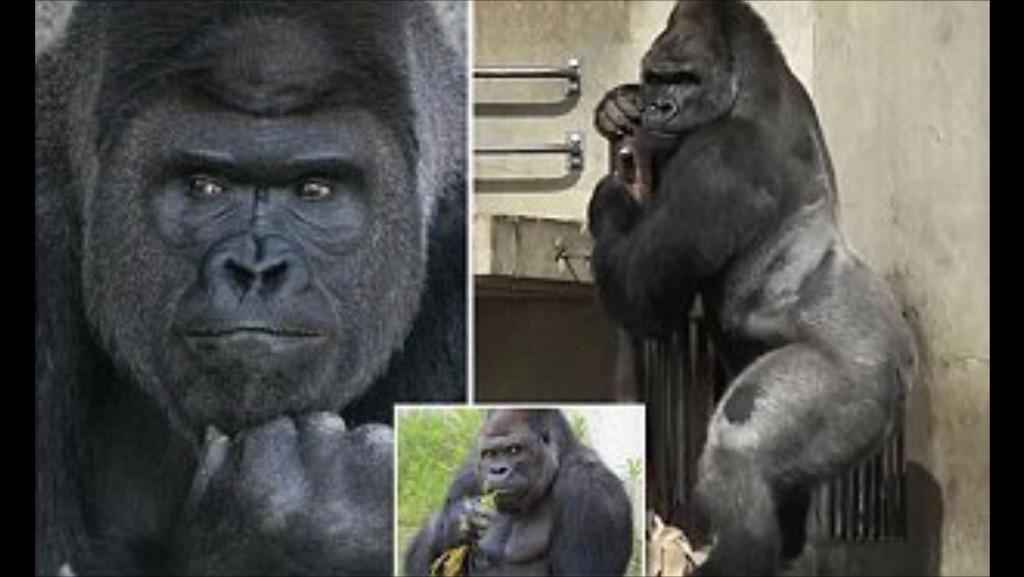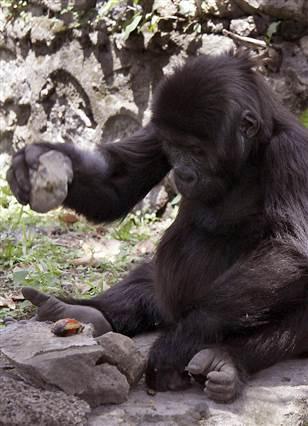The first image is the image on the left, the second image is the image on the right. For the images shown, is this caption "At least one person is present with an ape in one of the images." true? Answer yes or no. No. 